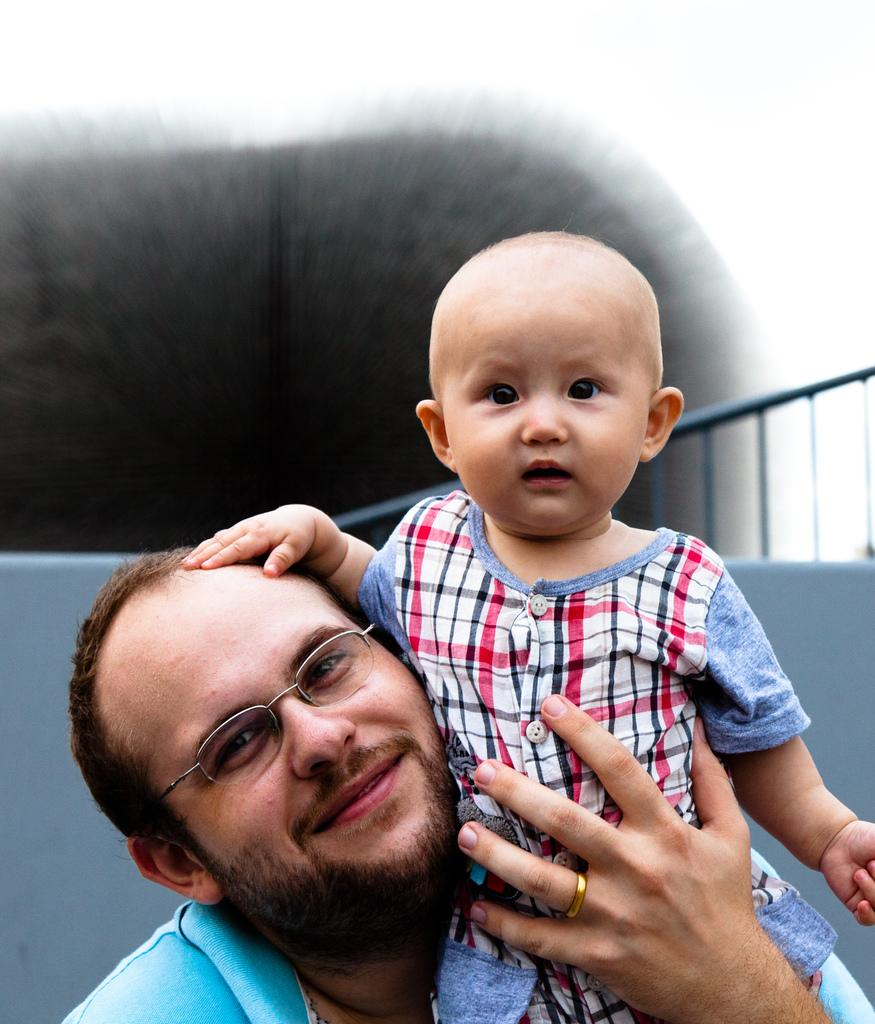What is the main subject of the image? The main subject of the image is a man. What is the man doing in the image? The man is holding a child in his hands. What type of watch is the man wearing in the image? There is no watch visible on the man in the image. What color is the paint on the child's shirt in the image? There is no paint or shirt visible on the child in the image, as the child is being held by the man. 